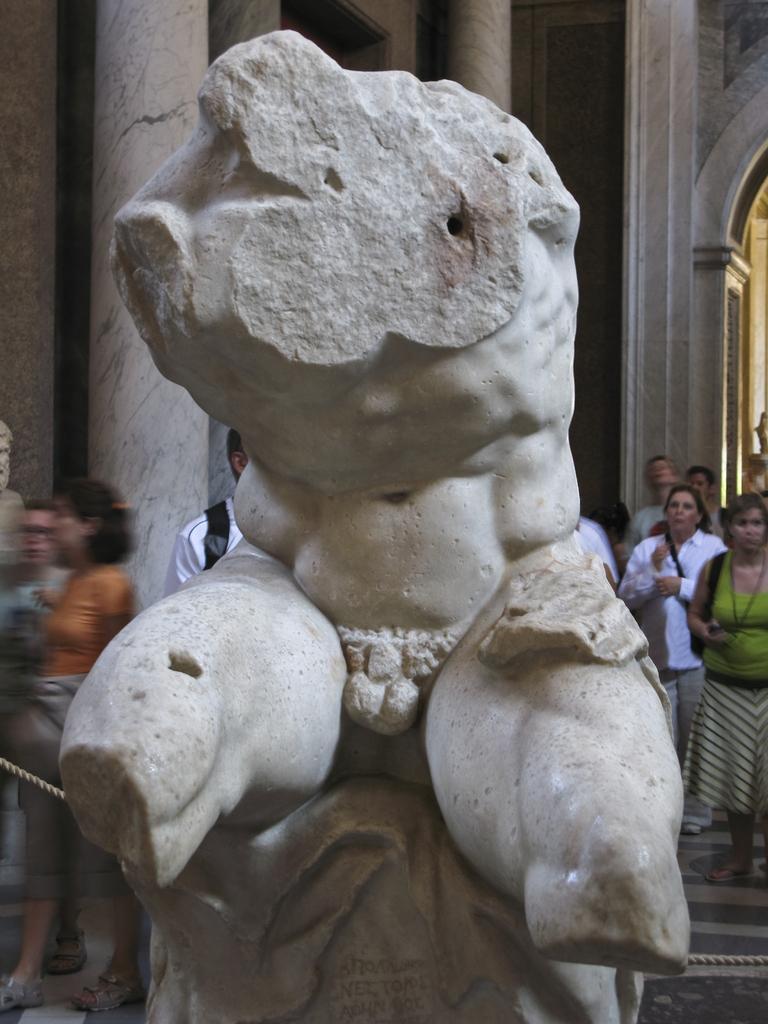Can you describe this image briefly? In this picture I can observe a statue in the middle of the picture. In the background I can observe some people. 